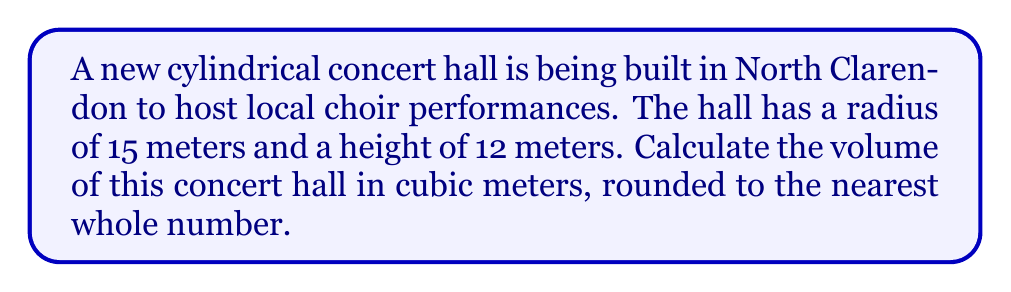Show me your answer to this math problem. To calculate the volume of a cylindrical concert hall, we need to use the formula for the volume of a cylinder:

$$V = \pi r^2 h$$

Where:
$V$ = volume of the cylinder
$\pi$ = pi (approximately 3.14159)
$r$ = radius of the base
$h$ = height of the cylinder

Given:
- Radius ($r$) = 15 meters
- Height ($h$) = 12 meters

Let's substitute these values into the formula:

$$V = \pi (15\text{ m})^2 (12\text{ m})$$

Now, let's calculate step by step:

1) First, calculate $r^2$:
   $15^2 = 225$

2) Multiply by $\pi$:
   $\pi \times 225 \approx 706.86$

3) Multiply by the height:
   $706.86 \times 12 \approx 8,482.30$

Therefore, the volume of the cylindrical concert hall is approximately 8,482.30 cubic meters.

Rounding to the nearest whole number as requested in the question:

$$V \approx 8,482 \text{ m}^3$$

[asy]
import geometry;

size(200);
real r = 15;
real h = 12;
real scale = 5;

path base = Circle((0,0), r/scale);
path top = shift(0,h/scale)*base;

draw(base);
draw(top);
draw((r/scale,0)--(r/scale,h/scale));
draw((-r/scale,0)--(-r/scale,h/scale));

label("15 m", (r/scale,h/(2*scale)), E);
label("12 m", (0,h/(2*scale)), W);

[/asy]
Answer: 8,482 cubic meters 